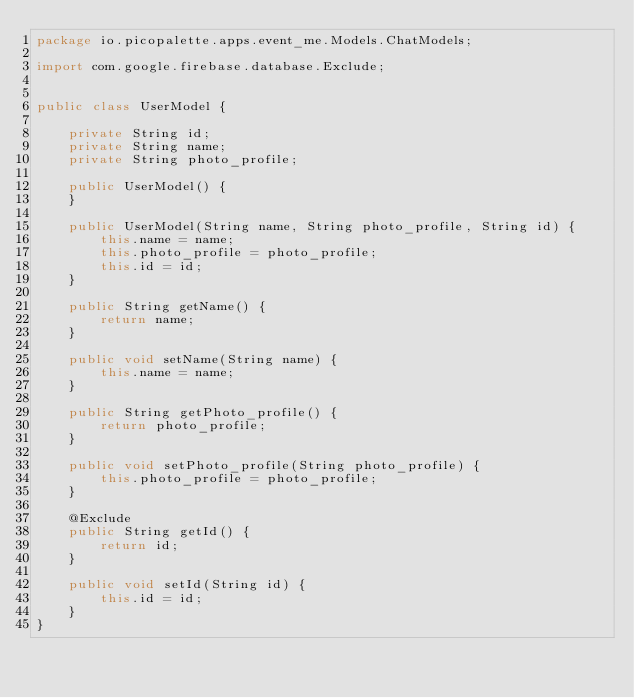<code> <loc_0><loc_0><loc_500><loc_500><_Java_>package io.picopalette.apps.event_me.Models.ChatModels;

import com.google.firebase.database.Exclude;


public class UserModel {

    private String id;
    private String name;
    private String photo_profile;

    public UserModel() {
    }

    public UserModel(String name, String photo_profile, String id) {
        this.name = name;
        this.photo_profile = photo_profile;
        this.id = id;
    }

    public String getName() {
        return name;
    }

    public void setName(String name) {
        this.name = name;
    }

    public String getPhoto_profile() {
        return photo_profile;
    }

    public void setPhoto_profile(String photo_profile) {
        this.photo_profile = photo_profile;
    }

    @Exclude
    public String getId() {
        return id;
    }

    public void setId(String id) {
        this.id = id;
    }
}
</code> 